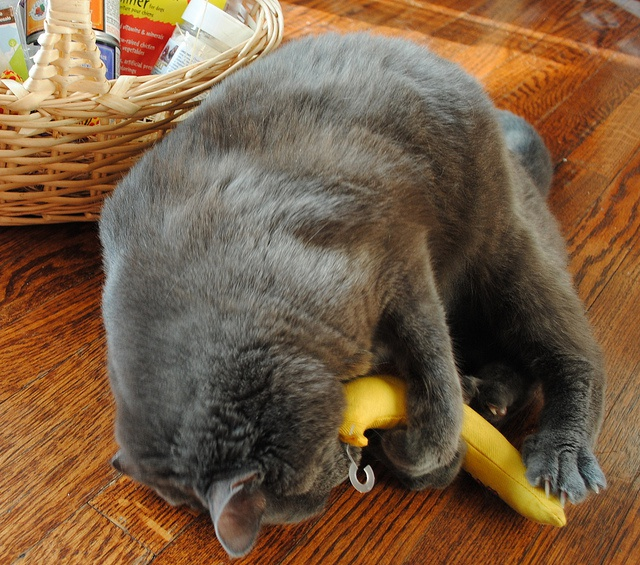Describe the objects in this image and their specific colors. I can see cat in lightgray, gray, black, and darkgray tones and banana in lightgray, olive, and gold tones in this image. 